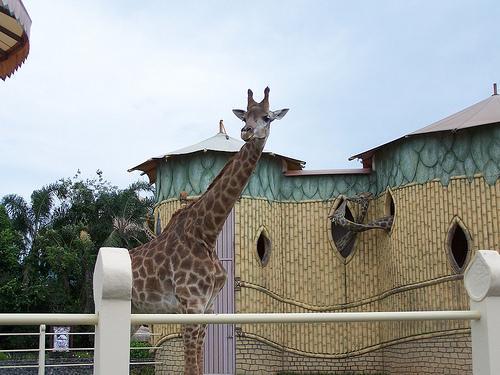How many fake giraffe are there?
Give a very brief answer. 2. How many giraffe are there?
Give a very brief answer. 1. How many giraffes are inside the building?
Give a very brief answer. 2. 